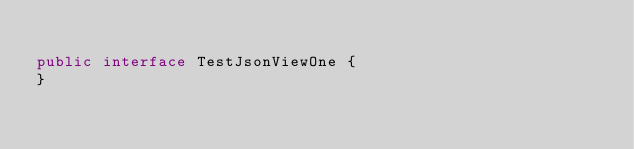<code> <loc_0><loc_0><loc_500><loc_500><_Java_>
public interface TestJsonViewOne {
}
</code> 